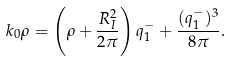<formula> <loc_0><loc_0><loc_500><loc_500>k _ { 0 } \rho = \left ( \rho + \frac { R _ { I } ^ { 2 } } { 2 \pi } \right ) q _ { 1 } ^ { - } + \frac { ( q _ { 1 } ^ { - } ) ^ { 3 } } { 8 \pi } .</formula> 